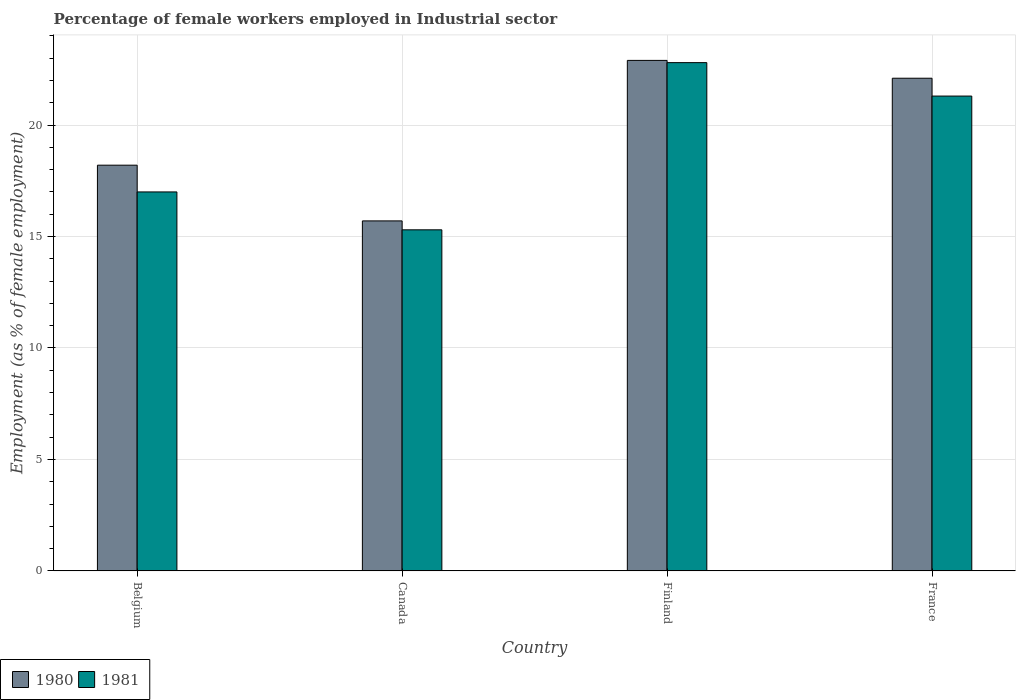How many different coloured bars are there?
Ensure brevity in your answer.  2. How many groups of bars are there?
Ensure brevity in your answer.  4. Are the number of bars per tick equal to the number of legend labels?
Your response must be concise. Yes. How many bars are there on the 4th tick from the left?
Your answer should be very brief. 2. What is the label of the 2nd group of bars from the left?
Offer a terse response. Canada. In how many cases, is the number of bars for a given country not equal to the number of legend labels?
Keep it short and to the point. 0. What is the percentage of females employed in Industrial sector in 1981 in Belgium?
Your answer should be very brief. 17. Across all countries, what is the maximum percentage of females employed in Industrial sector in 1980?
Ensure brevity in your answer.  22.9. Across all countries, what is the minimum percentage of females employed in Industrial sector in 1981?
Your answer should be compact. 15.3. In which country was the percentage of females employed in Industrial sector in 1980 maximum?
Give a very brief answer. Finland. What is the total percentage of females employed in Industrial sector in 1980 in the graph?
Your response must be concise. 78.9. What is the difference between the percentage of females employed in Industrial sector in 1980 in Finland and that in France?
Make the answer very short. 0.8. What is the difference between the percentage of females employed in Industrial sector in 1980 in Belgium and the percentage of females employed in Industrial sector in 1981 in Canada?
Provide a succinct answer. 2.9. What is the average percentage of females employed in Industrial sector in 1981 per country?
Provide a short and direct response. 19.1. What is the difference between the percentage of females employed in Industrial sector of/in 1981 and percentage of females employed in Industrial sector of/in 1980 in Canada?
Provide a short and direct response. -0.4. In how many countries, is the percentage of females employed in Industrial sector in 1980 greater than 2 %?
Your answer should be very brief. 4. What is the ratio of the percentage of females employed in Industrial sector in 1981 in Canada to that in France?
Your answer should be compact. 0.72. Is the difference between the percentage of females employed in Industrial sector in 1981 in Canada and France greater than the difference between the percentage of females employed in Industrial sector in 1980 in Canada and France?
Your answer should be compact. Yes. What is the difference between the highest and the second highest percentage of females employed in Industrial sector in 1980?
Ensure brevity in your answer.  -4.7. What is the difference between the highest and the lowest percentage of females employed in Industrial sector in 1980?
Your answer should be compact. 7.2. Is the sum of the percentage of females employed in Industrial sector in 1981 in Canada and Finland greater than the maximum percentage of females employed in Industrial sector in 1980 across all countries?
Make the answer very short. Yes. What does the 1st bar from the left in Belgium represents?
Give a very brief answer. 1980. What does the 1st bar from the right in Canada represents?
Make the answer very short. 1981. How many bars are there?
Your answer should be compact. 8. What is the difference between two consecutive major ticks on the Y-axis?
Provide a short and direct response. 5. Does the graph contain grids?
Ensure brevity in your answer.  Yes. How many legend labels are there?
Provide a short and direct response. 2. What is the title of the graph?
Make the answer very short. Percentage of female workers employed in Industrial sector. What is the label or title of the X-axis?
Your response must be concise. Country. What is the label or title of the Y-axis?
Provide a short and direct response. Employment (as % of female employment). What is the Employment (as % of female employment) of 1980 in Belgium?
Offer a very short reply. 18.2. What is the Employment (as % of female employment) of 1980 in Canada?
Make the answer very short. 15.7. What is the Employment (as % of female employment) of 1981 in Canada?
Your answer should be compact. 15.3. What is the Employment (as % of female employment) of 1980 in Finland?
Give a very brief answer. 22.9. What is the Employment (as % of female employment) of 1981 in Finland?
Your response must be concise. 22.8. What is the Employment (as % of female employment) in 1980 in France?
Offer a terse response. 22.1. What is the Employment (as % of female employment) in 1981 in France?
Provide a short and direct response. 21.3. Across all countries, what is the maximum Employment (as % of female employment) of 1980?
Provide a short and direct response. 22.9. Across all countries, what is the maximum Employment (as % of female employment) in 1981?
Offer a very short reply. 22.8. Across all countries, what is the minimum Employment (as % of female employment) in 1980?
Your answer should be compact. 15.7. Across all countries, what is the minimum Employment (as % of female employment) in 1981?
Your response must be concise. 15.3. What is the total Employment (as % of female employment) in 1980 in the graph?
Provide a succinct answer. 78.9. What is the total Employment (as % of female employment) in 1981 in the graph?
Offer a terse response. 76.4. What is the difference between the Employment (as % of female employment) of 1980 in Belgium and that in Canada?
Provide a succinct answer. 2.5. What is the difference between the Employment (as % of female employment) of 1981 in Belgium and that in Canada?
Your answer should be very brief. 1.7. What is the difference between the Employment (as % of female employment) of 1980 in Belgium and that in Finland?
Offer a very short reply. -4.7. What is the difference between the Employment (as % of female employment) in 1981 in Belgium and that in Finland?
Your response must be concise. -5.8. What is the difference between the Employment (as % of female employment) in 1980 in Belgium and that in France?
Keep it short and to the point. -3.9. What is the difference between the Employment (as % of female employment) of 1981 in Belgium and that in France?
Keep it short and to the point. -4.3. What is the difference between the Employment (as % of female employment) of 1980 in Canada and that in Finland?
Make the answer very short. -7.2. What is the difference between the Employment (as % of female employment) of 1980 in Canada and that in France?
Make the answer very short. -6.4. What is the difference between the Employment (as % of female employment) of 1981 in Canada and that in France?
Give a very brief answer. -6. What is the difference between the Employment (as % of female employment) in 1981 in Finland and that in France?
Offer a very short reply. 1.5. What is the difference between the Employment (as % of female employment) in 1980 in Belgium and the Employment (as % of female employment) in 1981 in Canada?
Provide a short and direct response. 2.9. What is the difference between the Employment (as % of female employment) in 1980 in Belgium and the Employment (as % of female employment) in 1981 in Finland?
Make the answer very short. -4.6. What is the difference between the Employment (as % of female employment) of 1980 in Belgium and the Employment (as % of female employment) of 1981 in France?
Give a very brief answer. -3.1. What is the difference between the Employment (as % of female employment) in 1980 in Canada and the Employment (as % of female employment) in 1981 in France?
Your answer should be compact. -5.6. What is the difference between the Employment (as % of female employment) of 1980 in Finland and the Employment (as % of female employment) of 1981 in France?
Offer a very short reply. 1.6. What is the average Employment (as % of female employment) of 1980 per country?
Ensure brevity in your answer.  19.73. What is the average Employment (as % of female employment) of 1981 per country?
Provide a short and direct response. 19.1. What is the difference between the Employment (as % of female employment) of 1980 and Employment (as % of female employment) of 1981 in Finland?
Offer a very short reply. 0.1. What is the difference between the Employment (as % of female employment) in 1980 and Employment (as % of female employment) in 1981 in France?
Provide a short and direct response. 0.8. What is the ratio of the Employment (as % of female employment) in 1980 in Belgium to that in Canada?
Your answer should be compact. 1.16. What is the ratio of the Employment (as % of female employment) in 1981 in Belgium to that in Canada?
Offer a terse response. 1.11. What is the ratio of the Employment (as % of female employment) in 1980 in Belgium to that in Finland?
Keep it short and to the point. 0.79. What is the ratio of the Employment (as % of female employment) of 1981 in Belgium to that in Finland?
Your response must be concise. 0.75. What is the ratio of the Employment (as % of female employment) in 1980 in Belgium to that in France?
Offer a terse response. 0.82. What is the ratio of the Employment (as % of female employment) of 1981 in Belgium to that in France?
Provide a short and direct response. 0.8. What is the ratio of the Employment (as % of female employment) of 1980 in Canada to that in Finland?
Provide a short and direct response. 0.69. What is the ratio of the Employment (as % of female employment) in 1981 in Canada to that in Finland?
Offer a terse response. 0.67. What is the ratio of the Employment (as % of female employment) of 1980 in Canada to that in France?
Provide a succinct answer. 0.71. What is the ratio of the Employment (as % of female employment) in 1981 in Canada to that in France?
Offer a very short reply. 0.72. What is the ratio of the Employment (as % of female employment) in 1980 in Finland to that in France?
Provide a succinct answer. 1.04. What is the ratio of the Employment (as % of female employment) of 1981 in Finland to that in France?
Offer a terse response. 1.07. What is the difference between the highest and the second highest Employment (as % of female employment) of 1980?
Provide a short and direct response. 0.8. What is the difference between the highest and the second highest Employment (as % of female employment) of 1981?
Give a very brief answer. 1.5. What is the difference between the highest and the lowest Employment (as % of female employment) of 1980?
Your response must be concise. 7.2. What is the difference between the highest and the lowest Employment (as % of female employment) of 1981?
Ensure brevity in your answer.  7.5. 